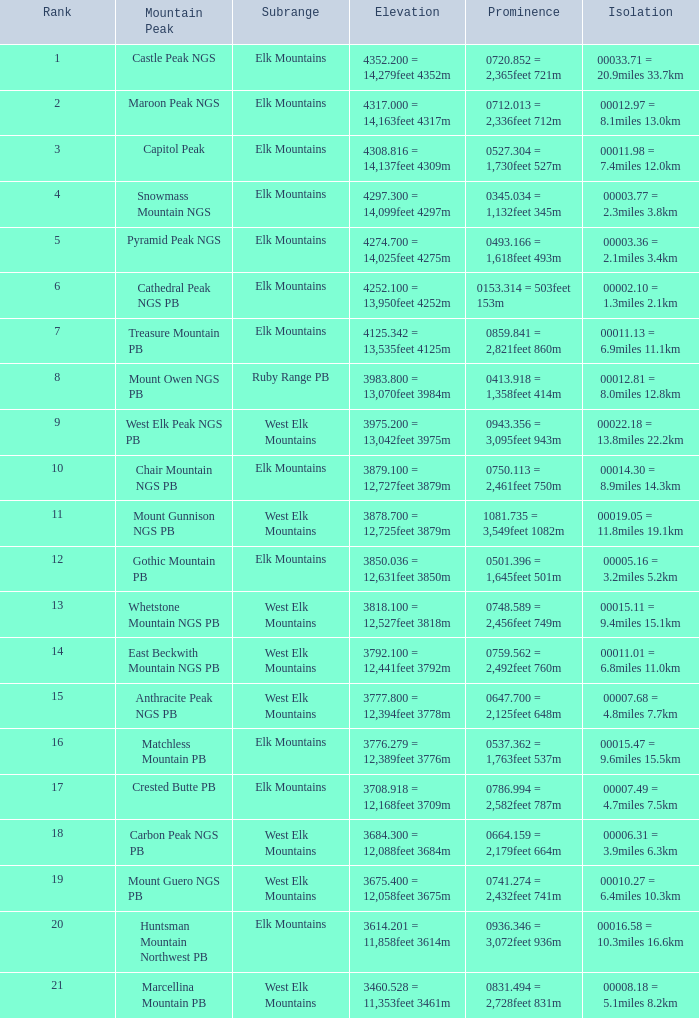What is the prominence of the mountain peak of matchless mountain pb? 0537.362 = 1,763feet 537m. 